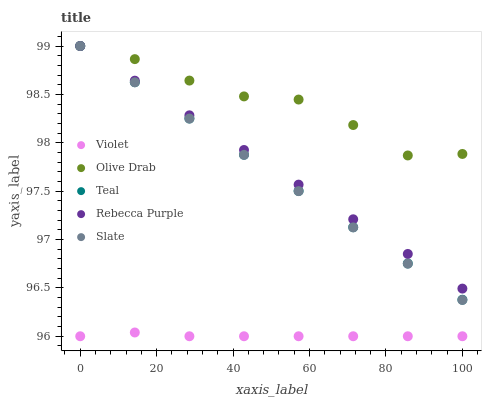Does Violet have the minimum area under the curve?
Answer yes or no. Yes. Does Olive Drab have the maximum area under the curve?
Answer yes or no. Yes. Does Slate have the minimum area under the curve?
Answer yes or no. No. Does Slate have the maximum area under the curve?
Answer yes or no. No. Is Rebecca Purple the smoothest?
Answer yes or no. Yes. Is Olive Drab the roughest?
Answer yes or no. Yes. Is Slate the smoothest?
Answer yes or no. No. Is Slate the roughest?
Answer yes or no. No. Does Violet have the lowest value?
Answer yes or no. Yes. Does Slate have the lowest value?
Answer yes or no. No. Does Olive Drab have the highest value?
Answer yes or no. Yes. Does Violet have the highest value?
Answer yes or no. No. Is Violet less than Teal?
Answer yes or no. Yes. Is Olive Drab greater than Violet?
Answer yes or no. Yes. Does Rebecca Purple intersect Olive Drab?
Answer yes or no. Yes. Is Rebecca Purple less than Olive Drab?
Answer yes or no. No. Is Rebecca Purple greater than Olive Drab?
Answer yes or no. No. Does Violet intersect Teal?
Answer yes or no. No. 